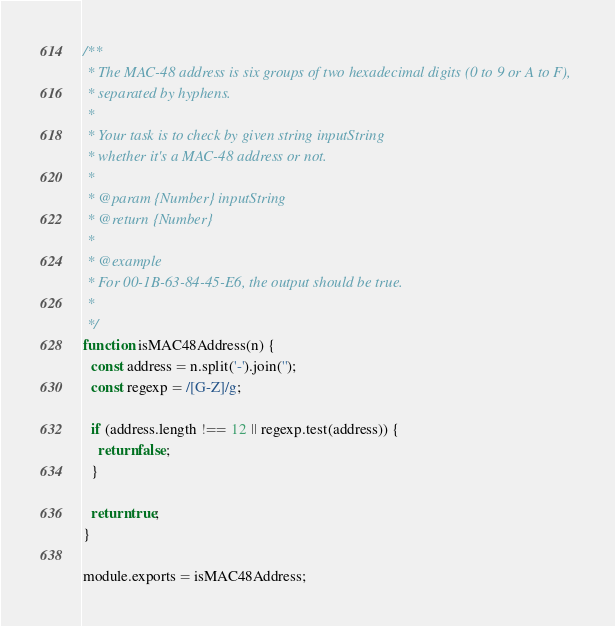Convert code to text. <code><loc_0><loc_0><loc_500><loc_500><_JavaScript_>/**
 * The MAC-48 address is six groups of two hexadecimal digits (0 to 9 or A to F),
 * separated by hyphens.
 *
 * Your task is to check by given string inputString
 * whether it's a MAC-48 address or not.
 *
 * @param {Number} inputString
 * @return {Number}
 *
 * @example
 * For 00-1B-63-84-45-E6, the output should be true.
 *
 */
function isMAC48Address(n) {
  const address = n.split('-').join('');
  const regexp = /[G-Z]/g;

  if (address.length !== 12 || regexp.test(address)) {
    return false;
  }

  return true;
}

module.exports = isMAC48Address;
</code> 